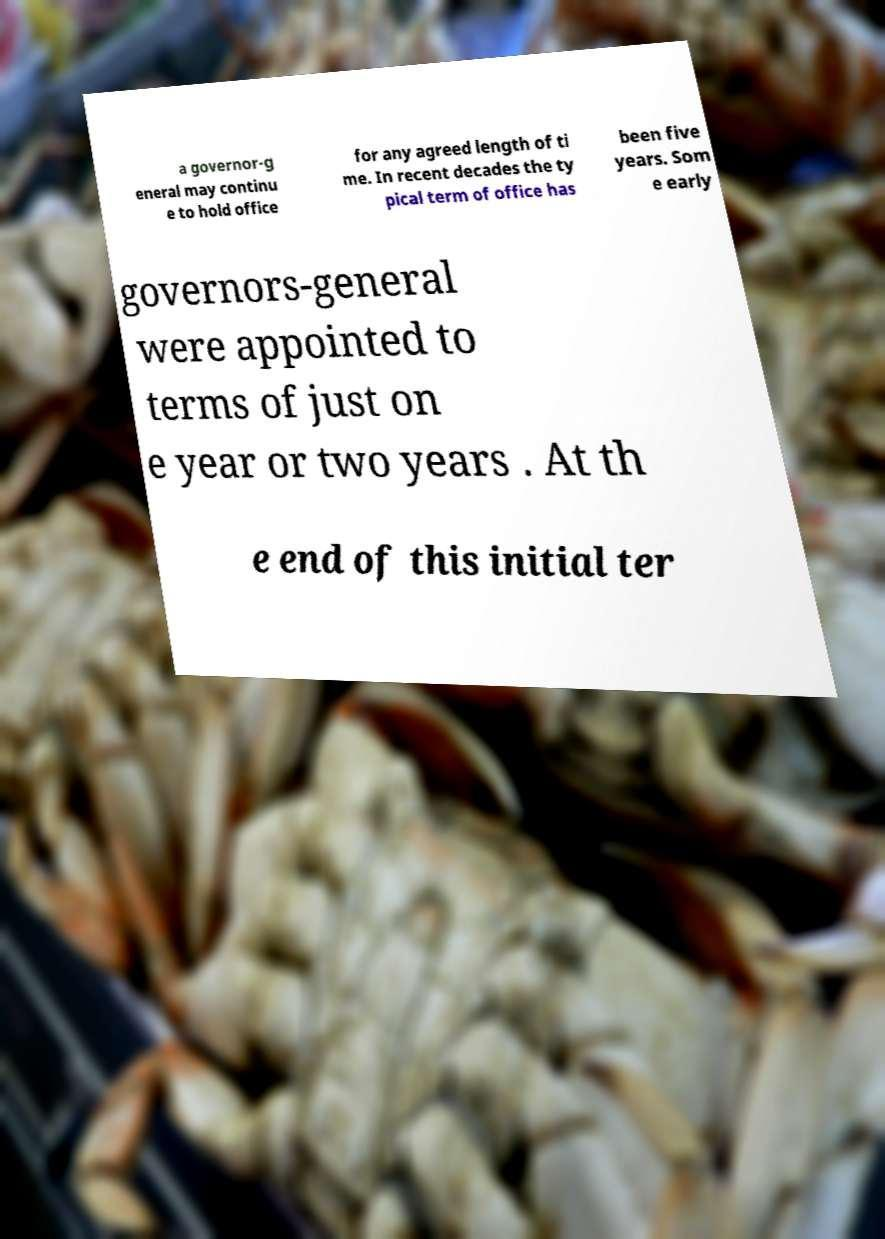Could you extract and type out the text from this image? a governor-g eneral may continu e to hold office for any agreed length of ti me. In recent decades the ty pical term of office has been five years. Som e early governors-general were appointed to terms of just on e year or two years . At th e end of this initial ter 